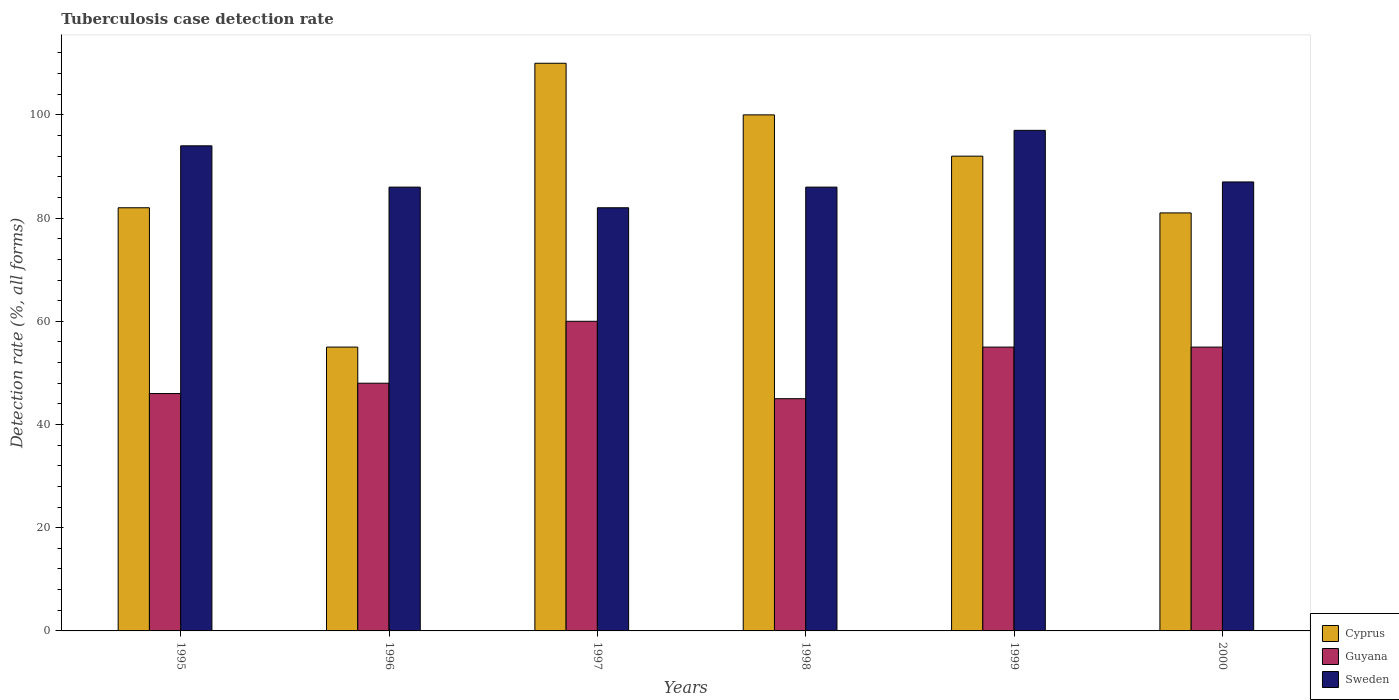How many different coloured bars are there?
Keep it short and to the point. 3. Are the number of bars on each tick of the X-axis equal?
Make the answer very short. Yes. How many bars are there on the 4th tick from the left?
Your response must be concise. 3. How many bars are there on the 5th tick from the right?
Your response must be concise. 3. In how many cases, is the number of bars for a given year not equal to the number of legend labels?
Make the answer very short. 0. What is the tuberculosis case detection rate in in Cyprus in 1996?
Give a very brief answer. 55. Across all years, what is the maximum tuberculosis case detection rate in in Sweden?
Your answer should be compact. 97. Across all years, what is the minimum tuberculosis case detection rate in in Cyprus?
Offer a terse response. 55. In which year was the tuberculosis case detection rate in in Guyana minimum?
Offer a terse response. 1998. What is the total tuberculosis case detection rate in in Cyprus in the graph?
Offer a terse response. 520. What is the difference between the tuberculosis case detection rate in in Sweden in 1996 and that in 1997?
Make the answer very short. 4. What is the difference between the tuberculosis case detection rate in in Guyana in 1997 and the tuberculosis case detection rate in in Cyprus in 1999?
Your answer should be very brief. -32. What is the average tuberculosis case detection rate in in Guyana per year?
Offer a terse response. 51.5. In the year 1999, what is the difference between the tuberculosis case detection rate in in Guyana and tuberculosis case detection rate in in Cyprus?
Your answer should be very brief. -37. What is the ratio of the tuberculosis case detection rate in in Guyana in 1995 to that in 1997?
Ensure brevity in your answer.  0.77. Is the tuberculosis case detection rate in in Guyana in 1997 less than that in 1999?
Offer a terse response. No. What is the difference between the highest and the second highest tuberculosis case detection rate in in Guyana?
Offer a very short reply. 5. What is the difference between the highest and the lowest tuberculosis case detection rate in in Sweden?
Your answer should be very brief. 15. In how many years, is the tuberculosis case detection rate in in Sweden greater than the average tuberculosis case detection rate in in Sweden taken over all years?
Make the answer very short. 2. What does the 3rd bar from the left in 1998 represents?
Your answer should be compact. Sweden. Is it the case that in every year, the sum of the tuberculosis case detection rate in in Cyprus and tuberculosis case detection rate in in Sweden is greater than the tuberculosis case detection rate in in Guyana?
Give a very brief answer. Yes. Are all the bars in the graph horizontal?
Provide a short and direct response. No. Does the graph contain grids?
Provide a succinct answer. No. How many legend labels are there?
Offer a terse response. 3. What is the title of the graph?
Offer a terse response. Tuberculosis case detection rate. Does "Syrian Arab Republic" appear as one of the legend labels in the graph?
Your answer should be compact. No. What is the label or title of the X-axis?
Offer a terse response. Years. What is the label or title of the Y-axis?
Offer a very short reply. Detection rate (%, all forms). What is the Detection rate (%, all forms) of Cyprus in 1995?
Your answer should be compact. 82. What is the Detection rate (%, all forms) in Guyana in 1995?
Make the answer very short. 46. What is the Detection rate (%, all forms) of Sweden in 1995?
Offer a terse response. 94. What is the Detection rate (%, all forms) of Cyprus in 1997?
Keep it short and to the point. 110. What is the Detection rate (%, all forms) of Cyprus in 1998?
Your response must be concise. 100. What is the Detection rate (%, all forms) in Cyprus in 1999?
Make the answer very short. 92. What is the Detection rate (%, all forms) in Sweden in 1999?
Your answer should be very brief. 97. What is the Detection rate (%, all forms) of Cyprus in 2000?
Ensure brevity in your answer.  81. Across all years, what is the maximum Detection rate (%, all forms) in Cyprus?
Provide a succinct answer. 110. Across all years, what is the maximum Detection rate (%, all forms) of Sweden?
Make the answer very short. 97. Across all years, what is the minimum Detection rate (%, all forms) of Cyprus?
Keep it short and to the point. 55. Across all years, what is the minimum Detection rate (%, all forms) of Sweden?
Your response must be concise. 82. What is the total Detection rate (%, all forms) of Cyprus in the graph?
Keep it short and to the point. 520. What is the total Detection rate (%, all forms) in Guyana in the graph?
Your response must be concise. 309. What is the total Detection rate (%, all forms) in Sweden in the graph?
Your response must be concise. 532. What is the difference between the Detection rate (%, all forms) in Cyprus in 1995 and that in 1996?
Make the answer very short. 27. What is the difference between the Detection rate (%, all forms) in Sweden in 1995 and that in 1996?
Keep it short and to the point. 8. What is the difference between the Detection rate (%, all forms) in Cyprus in 1995 and that in 1997?
Your answer should be very brief. -28. What is the difference between the Detection rate (%, all forms) of Sweden in 1995 and that in 1997?
Your response must be concise. 12. What is the difference between the Detection rate (%, all forms) of Cyprus in 1995 and that in 1998?
Keep it short and to the point. -18. What is the difference between the Detection rate (%, all forms) of Cyprus in 1995 and that in 1999?
Make the answer very short. -10. What is the difference between the Detection rate (%, all forms) in Guyana in 1995 and that in 1999?
Ensure brevity in your answer.  -9. What is the difference between the Detection rate (%, all forms) of Sweden in 1995 and that in 1999?
Make the answer very short. -3. What is the difference between the Detection rate (%, all forms) of Guyana in 1995 and that in 2000?
Your response must be concise. -9. What is the difference between the Detection rate (%, all forms) in Cyprus in 1996 and that in 1997?
Your answer should be very brief. -55. What is the difference between the Detection rate (%, all forms) in Guyana in 1996 and that in 1997?
Offer a very short reply. -12. What is the difference between the Detection rate (%, all forms) in Cyprus in 1996 and that in 1998?
Ensure brevity in your answer.  -45. What is the difference between the Detection rate (%, all forms) in Guyana in 1996 and that in 1998?
Provide a short and direct response. 3. What is the difference between the Detection rate (%, all forms) in Sweden in 1996 and that in 1998?
Your response must be concise. 0. What is the difference between the Detection rate (%, all forms) in Cyprus in 1996 and that in 1999?
Your answer should be very brief. -37. What is the difference between the Detection rate (%, all forms) of Guyana in 1996 and that in 1999?
Keep it short and to the point. -7. What is the difference between the Detection rate (%, all forms) of Cyprus in 1996 and that in 2000?
Your answer should be very brief. -26. What is the difference between the Detection rate (%, all forms) in Guyana in 1996 and that in 2000?
Give a very brief answer. -7. What is the difference between the Detection rate (%, all forms) of Guyana in 1997 and that in 1998?
Keep it short and to the point. 15. What is the difference between the Detection rate (%, all forms) in Cyprus in 1997 and that in 1999?
Give a very brief answer. 18. What is the difference between the Detection rate (%, all forms) of Guyana in 1997 and that in 1999?
Make the answer very short. 5. What is the difference between the Detection rate (%, all forms) of Sweden in 1997 and that in 1999?
Your answer should be very brief. -15. What is the difference between the Detection rate (%, all forms) in Cyprus in 1997 and that in 2000?
Provide a short and direct response. 29. What is the difference between the Detection rate (%, all forms) of Guyana in 1997 and that in 2000?
Your answer should be compact. 5. What is the difference between the Detection rate (%, all forms) of Sweden in 1997 and that in 2000?
Ensure brevity in your answer.  -5. What is the difference between the Detection rate (%, all forms) in Cyprus in 1998 and that in 1999?
Provide a succinct answer. 8. What is the difference between the Detection rate (%, all forms) in Sweden in 1998 and that in 1999?
Your answer should be compact. -11. What is the difference between the Detection rate (%, all forms) in Sweden in 1999 and that in 2000?
Offer a very short reply. 10. What is the difference between the Detection rate (%, all forms) of Cyprus in 1995 and the Detection rate (%, all forms) of Guyana in 1996?
Provide a succinct answer. 34. What is the difference between the Detection rate (%, all forms) of Cyprus in 1995 and the Detection rate (%, all forms) of Sweden in 1996?
Your answer should be very brief. -4. What is the difference between the Detection rate (%, all forms) in Cyprus in 1995 and the Detection rate (%, all forms) in Guyana in 1997?
Your response must be concise. 22. What is the difference between the Detection rate (%, all forms) in Guyana in 1995 and the Detection rate (%, all forms) in Sweden in 1997?
Your response must be concise. -36. What is the difference between the Detection rate (%, all forms) in Cyprus in 1995 and the Detection rate (%, all forms) in Guyana in 1998?
Your response must be concise. 37. What is the difference between the Detection rate (%, all forms) of Cyprus in 1995 and the Detection rate (%, all forms) of Guyana in 1999?
Provide a short and direct response. 27. What is the difference between the Detection rate (%, all forms) of Guyana in 1995 and the Detection rate (%, all forms) of Sweden in 1999?
Provide a succinct answer. -51. What is the difference between the Detection rate (%, all forms) in Cyprus in 1995 and the Detection rate (%, all forms) in Sweden in 2000?
Give a very brief answer. -5. What is the difference between the Detection rate (%, all forms) in Guyana in 1995 and the Detection rate (%, all forms) in Sweden in 2000?
Ensure brevity in your answer.  -41. What is the difference between the Detection rate (%, all forms) in Cyprus in 1996 and the Detection rate (%, all forms) in Sweden in 1997?
Provide a succinct answer. -27. What is the difference between the Detection rate (%, all forms) of Guyana in 1996 and the Detection rate (%, all forms) of Sweden in 1997?
Ensure brevity in your answer.  -34. What is the difference between the Detection rate (%, all forms) of Cyprus in 1996 and the Detection rate (%, all forms) of Sweden in 1998?
Give a very brief answer. -31. What is the difference between the Detection rate (%, all forms) in Guyana in 1996 and the Detection rate (%, all forms) in Sweden in 1998?
Give a very brief answer. -38. What is the difference between the Detection rate (%, all forms) of Cyprus in 1996 and the Detection rate (%, all forms) of Sweden in 1999?
Ensure brevity in your answer.  -42. What is the difference between the Detection rate (%, all forms) of Guyana in 1996 and the Detection rate (%, all forms) of Sweden in 1999?
Offer a very short reply. -49. What is the difference between the Detection rate (%, all forms) in Cyprus in 1996 and the Detection rate (%, all forms) in Guyana in 2000?
Provide a short and direct response. 0. What is the difference between the Detection rate (%, all forms) of Cyprus in 1996 and the Detection rate (%, all forms) of Sweden in 2000?
Your response must be concise. -32. What is the difference between the Detection rate (%, all forms) in Guyana in 1996 and the Detection rate (%, all forms) in Sweden in 2000?
Make the answer very short. -39. What is the difference between the Detection rate (%, all forms) of Guyana in 1997 and the Detection rate (%, all forms) of Sweden in 1998?
Offer a terse response. -26. What is the difference between the Detection rate (%, all forms) in Guyana in 1997 and the Detection rate (%, all forms) in Sweden in 1999?
Make the answer very short. -37. What is the difference between the Detection rate (%, all forms) of Guyana in 1997 and the Detection rate (%, all forms) of Sweden in 2000?
Your answer should be compact. -27. What is the difference between the Detection rate (%, all forms) of Guyana in 1998 and the Detection rate (%, all forms) of Sweden in 1999?
Offer a terse response. -52. What is the difference between the Detection rate (%, all forms) in Cyprus in 1998 and the Detection rate (%, all forms) in Guyana in 2000?
Provide a short and direct response. 45. What is the difference between the Detection rate (%, all forms) in Guyana in 1998 and the Detection rate (%, all forms) in Sweden in 2000?
Offer a very short reply. -42. What is the difference between the Detection rate (%, all forms) of Cyprus in 1999 and the Detection rate (%, all forms) of Sweden in 2000?
Provide a succinct answer. 5. What is the difference between the Detection rate (%, all forms) in Guyana in 1999 and the Detection rate (%, all forms) in Sweden in 2000?
Your answer should be compact. -32. What is the average Detection rate (%, all forms) of Cyprus per year?
Provide a short and direct response. 86.67. What is the average Detection rate (%, all forms) in Guyana per year?
Offer a terse response. 51.5. What is the average Detection rate (%, all forms) in Sweden per year?
Make the answer very short. 88.67. In the year 1995, what is the difference between the Detection rate (%, all forms) of Cyprus and Detection rate (%, all forms) of Guyana?
Give a very brief answer. 36. In the year 1995, what is the difference between the Detection rate (%, all forms) in Cyprus and Detection rate (%, all forms) in Sweden?
Your response must be concise. -12. In the year 1995, what is the difference between the Detection rate (%, all forms) in Guyana and Detection rate (%, all forms) in Sweden?
Ensure brevity in your answer.  -48. In the year 1996, what is the difference between the Detection rate (%, all forms) in Cyprus and Detection rate (%, all forms) in Guyana?
Your response must be concise. 7. In the year 1996, what is the difference between the Detection rate (%, all forms) in Cyprus and Detection rate (%, all forms) in Sweden?
Give a very brief answer. -31. In the year 1996, what is the difference between the Detection rate (%, all forms) in Guyana and Detection rate (%, all forms) in Sweden?
Make the answer very short. -38. In the year 1997, what is the difference between the Detection rate (%, all forms) in Cyprus and Detection rate (%, all forms) in Guyana?
Provide a succinct answer. 50. In the year 1997, what is the difference between the Detection rate (%, all forms) in Cyprus and Detection rate (%, all forms) in Sweden?
Give a very brief answer. 28. In the year 1997, what is the difference between the Detection rate (%, all forms) in Guyana and Detection rate (%, all forms) in Sweden?
Provide a short and direct response. -22. In the year 1998, what is the difference between the Detection rate (%, all forms) of Cyprus and Detection rate (%, all forms) of Guyana?
Offer a very short reply. 55. In the year 1998, what is the difference between the Detection rate (%, all forms) in Guyana and Detection rate (%, all forms) in Sweden?
Offer a very short reply. -41. In the year 1999, what is the difference between the Detection rate (%, all forms) of Cyprus and Detection rate (%, all forms) of Guyana?
Offer a very short reply. 37. In the year 1999, what is the difference between the Detection rate (%, all forms) of Cyprus and Detection rate (%, all forms) of Sweden?
Keep it short and to the point. -5. In the year 1999, what is the difference between the Detection rate (%, all forms) in Guyana and Detection rate (%, all forms) in Sweden?
Give a very brief answer. -42. In the year 2000, what is the difference between the Detection rate (%, all forms) of Cyprus and Detection rate (%, all forms) of Sweden?
Provide a succinct answer. -6. In the year 2000, what is the difference between the Detection rate (%, all forms) of Guyana and Detection rate (%, all forms) of Sweden?
Keep it short and to the point. -32. What is the ratio of the Detection rate (%, all forms) of Cyprus in 1995 to that in 1996?
Your answer should be compact. 1.49. What is the ratio of the Detection rate (%, all forms) in Sweden in 1995 to that in 1996?
Offer a terse response. 1.09. What is the ratio of the Detection rate (%, all forms) of Cyprus in 1995 to that in 1997?
Your response must be concise. 0.75. What is the ratio of the Detection rate (%, all forms) of Guyana in 1995 to that in 1997?
Provide a short and direct response. 0.77. What is the ratio of the Detection rate (%, all forms) of Sweden in 1995 to that in 1997?
Offer a terse response. 1.15. What is the ratio of the Detection rate (%, all forms) of Cyprus in 1995 to that in 1998?
Keep it short and to the point. 0.82. What is the ratio of the Detection rate (%, all forms) of Guyana in 1995 to that in 1998?
Offer a terse response. 1.02. What is the ratio of the Detection rate (%, all forms) in Sweden in 1995 to that in 1998?
Offer a very short reply. 1.09. What is the ratio of the Detection rate (%, all forms) of Cyprus in 1995 to that in 1999?
Give a very brief answer. 0.89. What is the ratio of the Detection rate (%, all forms) in Guyana in 1995 to that in 1999?
Your answer should be very brief. 0.84. What is the ratio of the Detection rate (%, all forms) in Sweden in 1995 to that in 1999?
Provide a short and direct response. 0.97. What is the ratio of the Detection rate (%, all forms) of Cyprus in 1995 to that in 2000?
Offer a terse response. 1.01. What is the ratio of the Detection rate (%, all forms) in Guyana in 1995 to that in 2000?
Provide a short and direct response. 0.84. What is the ratio of the Detection rate (%, all forms) of Sweden in 1995 to that in 2000?
Offer a terse response. 1.08. What is the ratio of the Detection rate (%, all forms) in Cyprus in 1996 to that in 1997?
Ensure brevity in your answer.  0.5. What is the ratio of the Detection rate (%, all forms) in Sweden in 1996 to that in 1997?
Offer a very short reply. 1.05. What is the ratio of the Detection rate (%, all forms) of Cyprus in 1996 to that in 1998?
Provide a short and direct response. 0.55. What is the ratio of the Detection rate (%, all forms) of Guyana in 1996 to that in 1998?
Ensure brevity in your answer.  1.07. What is the ratio of the Detection rate (%, all forms) of Cyprus in 1996 to that in 1999?
Offer a very short reply. 0.6. What is the ratio of the Detection rate (%, all forms) of Guyana in 1996 to that in 1999?
Ensure brevity in your answer.  0.87. What is the ratio of the Detection rate (%, all forms) of Sweden in 1996 to that in 1999?
Your response must be concise. 0.89. What is the ratio of the Detection rate (%, all forms) in Cyprus in 1996 to that in 2000?
Your answer should be very brief. 0.68. What is the ratio of the Detection rate (%, all forms) in Guyana in 1996 to that in 2000?
Ensure brevity in your answer.  0.87. What is the ratio of the Detection rate (%, all forms) of Sweden in 1996 to that in 2000?
Your response must be concise. 0.99. What is the ratio of the Detection rate (%, all forms) of Cyprus in 1997 to that in 1998?
Make the answer very short. 1.1. What is the ratio of the Detection rate (%, all forms) of Guyana in 1997 to that in 1998?
Your answer should be compact. 1.33. What is the ratio of the Detection rate (%, all forms) in Sweden in 1997 to that in 1998?
Your answer should be compact. 0.95. What is the ratio of the Detection rate (%, all forms) of Cyprus in 1997 to that in 1999?
Ensure brevity in your answer.  1.2. What is the ratio of the Detection rate (%, all forms) in Sweden in 1997 to that in 1999?
Your response must be concise. 0.85. What is the ratio of the Detection rate (%, all forms) in Cyprus in 1997 to that in 2000?
Offer a very short reply. 1.36. What is the ratio of the Detection rate (%, all forms) in Guyana in 1997 to that in 2000?
Make the answer very short. 1.09. What is the ratio of the Detection rate (%, all forms) in Sweden in 1997 to that in 2000?
Your answer should be very brief. 0.94. What is the ratio of the Detection rate (%, all forms) in Cyprus in 1998 to that in 1999?
Provide a succinct answer. 1.09. What is the ratio of the Detection rate (%, all forms) in Guyana in 1998 to that in 1999?
Offer a terse response. 0.82. What is the ratio of the Detection rate (%, all forms) in Sweden in 1998 to that in 1999?
Keep it short and to the point. 0.89. What is the ratio of the Detection rate (%, all forms) of Cyprus in 1998 to that in 2000?
Your answer should be compact. 1.23. What is the ratio of the Detection rate (%, all forms) in Guyana in 1998 to that in 2000?
Offer a very short reply. 0.82. What is the ratio of the Detection rate (%, all forms) of Cyprus in 1999 to that in 2000?
Offer a very short reply. 1.14. What is the ratio of the Detection rate (%, all forms) in Guyana in 1999 to that in 2000?
Offer a terse response. 1. What is the ratio of the Detection rate (%, all forms) of Sweden in 1999 to that in 2000?
Your response must be concise. 1.11. What is the difference between the highest and the second highest Detection rate (%, all forms) of Cyprus?
Offer a terse response. 10. What is the difference between the highest and the second highest Detection rate (%, all forms) of Guyana?
Provide a succinct answer. 5. What is the difference between the highest and the second highest Detection rate (%, all forms) in Sweden?
Provide a short and direct response. 3. What is the difference between the highest and the lowest Detection rate (%, all forms) in Sweden?
Offer a terse response. 15. 